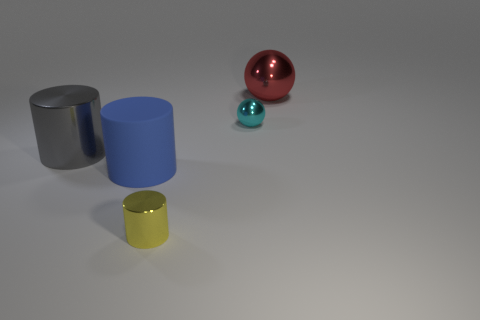Subtract all metallic cylinders. How many cylinders are left? 1 Add 2 large blue cylinders. How many objects exist? 7 Subtract all cyan spheres. How many spheres are left? 1 Subtract all cylinders. How many objects are left? 2 Subtract all purple cylinders. Subtract all green blocks. How many cylinders are left? 3 Subtract all blue rubber cylinders. Subtract all gray shiny cylinders. How many objects are left? 3 Add 4 blue objects. How many blue objects are left? 5 Add 1 blue rubber objects. How many blue rubber objects exist? 2 Subtract 0 cyan blocks. How many objects are left? 5 